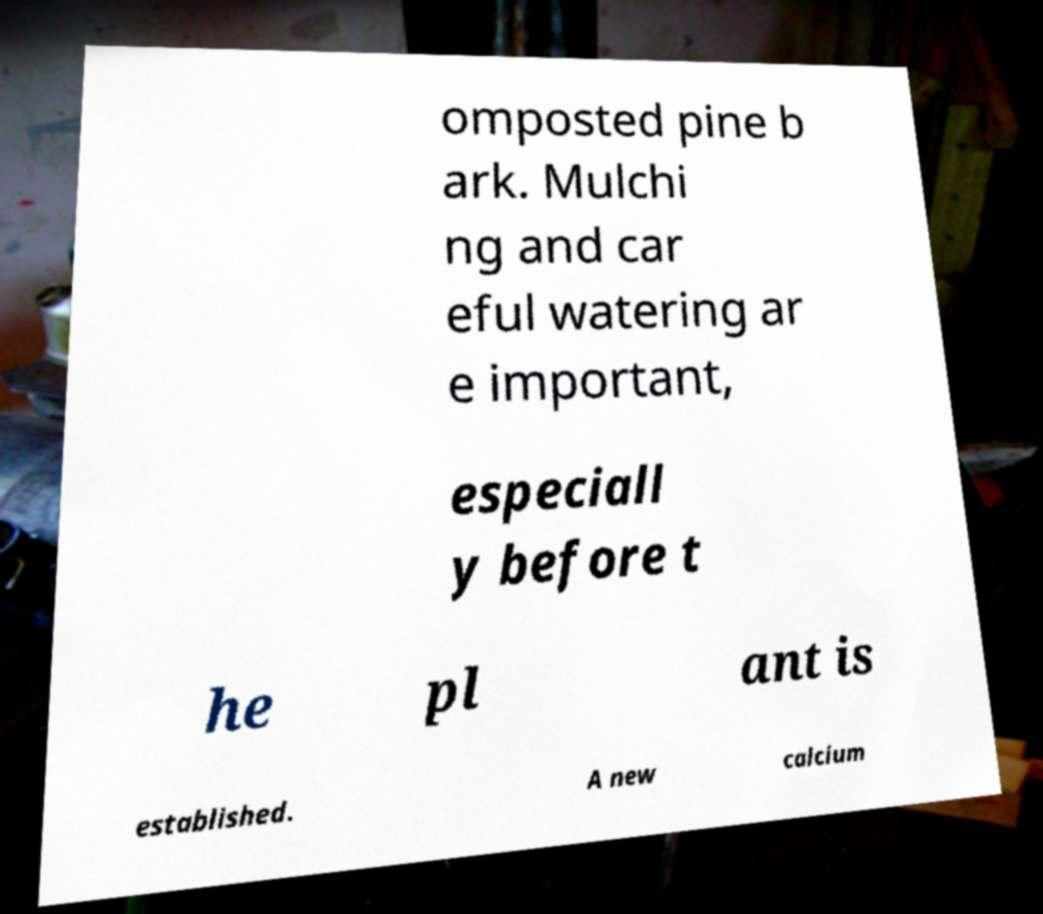Can you read and provide the text displayed in the image?This photo seems to have some interesting text. Can you extract and type it out for me? omposted pine b ark. Mulchi ng and car eful watering ar e important, especiall y before t he pl ant is established. A new calcium 